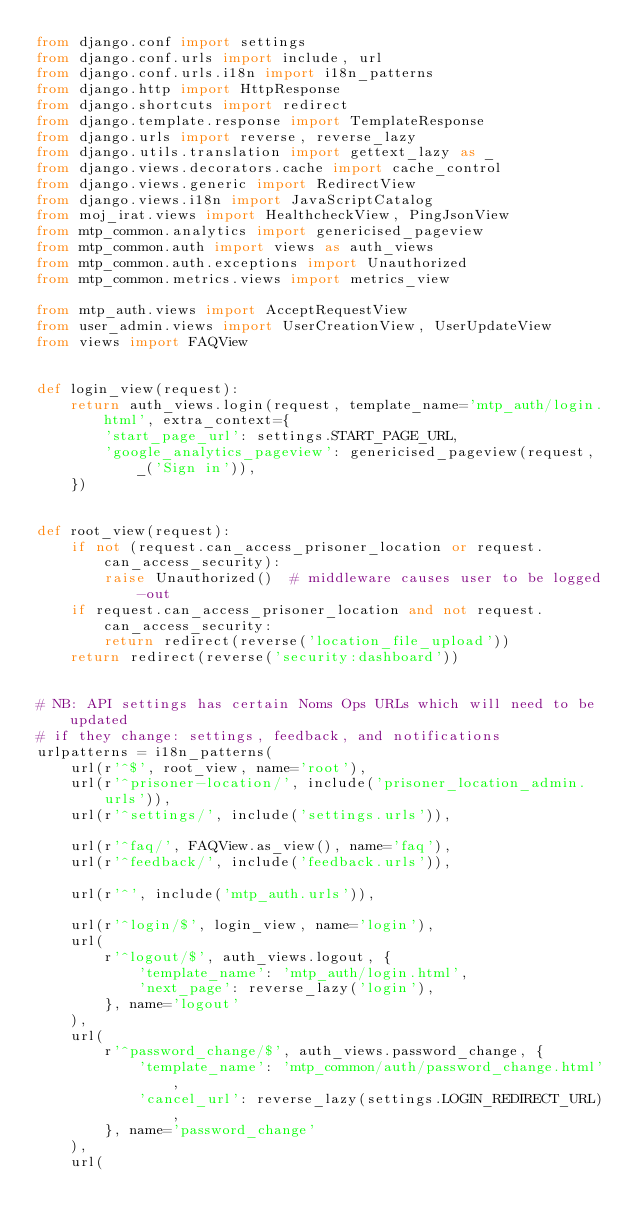<code> <loc_0><loc_0><loc_500><loc_500><_Python_>from django.conf import settings
from django.conf.urls import include, url
from django.conf.urls.i18n import i18n_patterns
from django.http import HttpResponse
from django.shortcuts import redirect
from django.template.response import TemplateResponse
from django.urls import reverse, reverse_lazy
from django.utils.translation import gettext_lazy as _
from django.views.decorators.cache import cache_control
from django.views.generic import RedirectView
from django.views.i18n import JavaScriptCatalog
from moj_irat.views import HealthcheckView, PingJsonView
from mtp_common.analytics import genericised_pageview
from mtp_common.auth import views as auth_views
from mtp_common.auth.exceptions import Unauthorized
from mtp_common.metrics.views import metrics_view

from mtp_auth.views import AcceptRequestView
from user_admin.views import UserCreationView, UserUpdateView
from views import FAQView


def login_view(request):
    return auth_views.login(request, template_name='mtp_auth/login.html', extra_context={
        'start_page_url': settings.START_PAGE_URL,
        'google_analytics_pageview': genericised_pageview(request, _('Sign in')),
    })


def root_view(request):
    if not (request.can_access_prisoner_location or request.can_access_security):
        raise Unauthorized()  # middleware causes user to be logged-out
    if request.can_access_prisoner_location and not request.can_access_security:
        return redirect(reverse('location_file_upload'))
    return redirect(reverse('security:dashboard'))


# NB: API settings has certain Noms Ops URLs which will need to be updated
# if they change: settings, feedback, and notifications
urlpatterns = i18n_patterns(
    url(r'^$', root_view, name='root'),
    url(r'^prisoner-location/', include('prisoner_location_admin.urls')),
    url(r'^settings/', include('settings.urls')),

    url(r'^faq/', FAQView.as_view(), name='faq'),
    url(r'^feedback/', include('feedback.urls')),

    url(r'^', include('mtp_auth.urls')),

    url(r'^login/$', login_view, name='login'),
    url(
        r'^logout/$', auth_views.logout, {
            'template_name': 'mtp_auth/login.html',
            'next_page': reverse_lazy('login'),
        }, name='logout'
    ),
    url(
        r'^password_change/$', auth_views.password_change, {
            'template_name': 'mtp_common/auth/password_change.html',
            'cancel_url': reverse_lazy(settings.LOGIN_REDIRECT_URL),
        }, name='password_change'
    ),
    url(</code> 